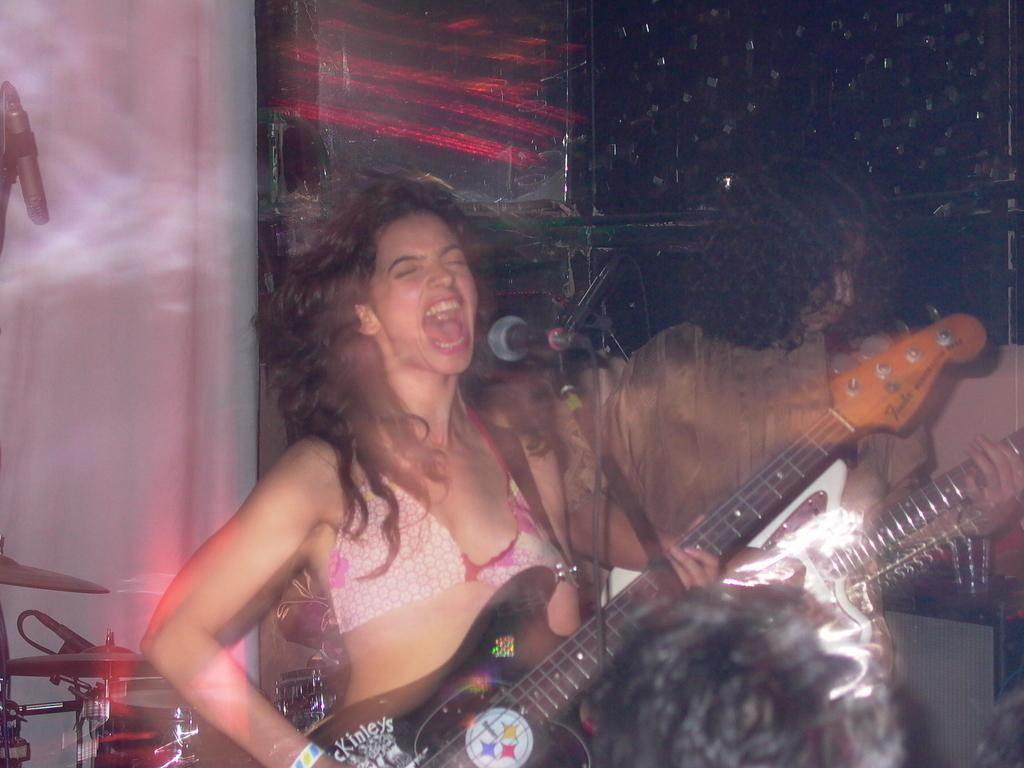What is the woman in the image doing? The woman is singing on a mic and playing a guitar. Can you describe the person behind the woman? The person behind the woman is also playing a guitar. What objects are present in the image that are related to music? There are musical instruments in the image, including a mic, a guitar, and another guitar. What type of flower is being used as a pen in the image? There is no flower or pen present in the image. 